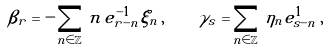Convert formula to latex. <formula><loc_0><loc_0><loc_500><loc_500>\beta _ { r } = - \sum _ { n \in \mathbb { Z } } \, n \, e ^ { - 1 } _ { r - n } \xi _ { n } \, , \quad \gamma _ { s } = \sum _ { n \in \mathbb { Z } } \, \eta _ { n } e ^ { 1 } _ { s - n } \, ,</formula> 